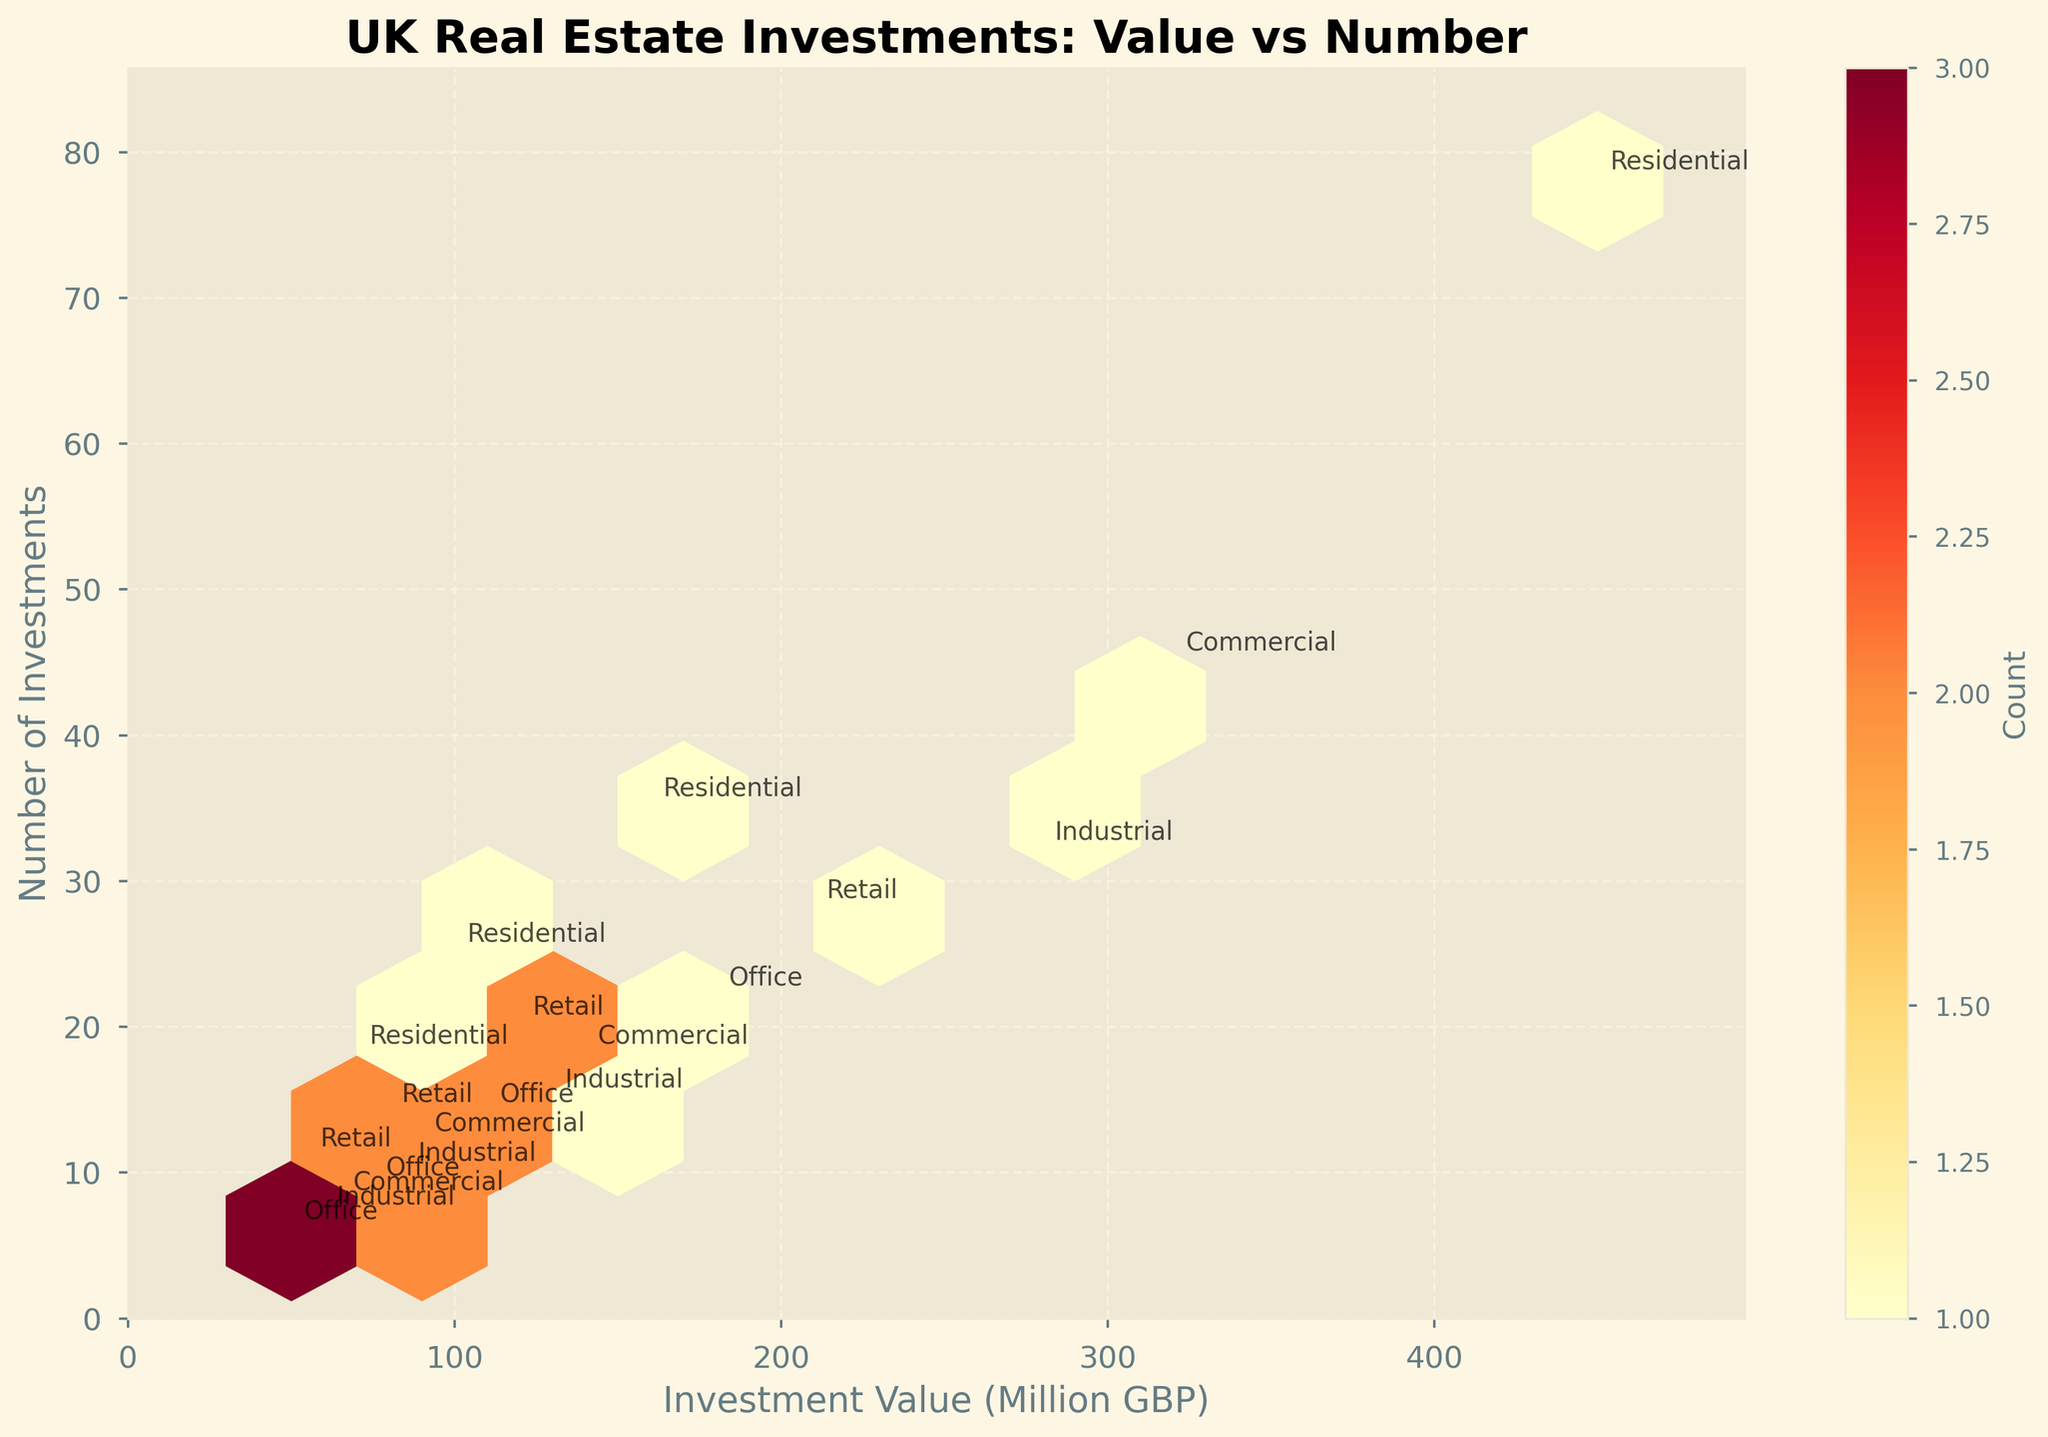What is the title of the figure? The title of the figure is usually found at the top of the plot. In this case, it is "UK Real Estate Investments: Value vs Number" as specified in the code.
Answer: UK Real Estate Investments: Value vs Number What do the axes represent? The x-axis represents the "Investment Value (Million GBP)" and the y-axis represents the "Number of Investments," as labeled in the figure.
Answer: Investment Value (Million GBP) and Number of Investments How many data points are there for Residential properties? There are several points labeled "Residential" across different locations. By inspecting the figure, you can count the annotations to determine there are 5 such points.
Answer: 5 Which property types have the highest and lowest investment values? To find the highest and lowest investment values, you look at the extremes on the x-axis and check the labeled points. Residential in London represents the highest value, while Office in Reading is the lowest.
Answer: Residential in London and Office in Reading How many property types have more than 20 investments? By counting the number of points where the y-values are greater than 20 and inspecting the property type labels, you can determine that Residential in London, Residential in Bristol, and Residential in Newcastle meet this criterion.
Answer: 3 What does the color gradient in the hexbin plot indicate? The color gradient of a hexbin plot typically indicates the density of the data points in that hexagon. In this plot, the color ranges from light yellow (lower density) to dark red (higher density).
Answer: Density of data points What is the average investment value of Commercial properties? Commercial properties have investment values of 320 (Manchester), 140 (Leeds), 90 (Nottingham), and 65 (Cambridge). Summing these values gives 615. Dividing by 4 gives an average of approximately 153.75 million GBP.
Answer: 153.75 million GBP Which city has the highest number of investments in the Retail property type? To find this, look at the y-values of points labeled "Retail." Edinburgh represents the highest number, with a value of 28.
Answer: Edinburgh How does the density of investments compare between Residential and Industrial property types? Observing the color density in hexbin regions marked with "Residential" and "Industrial" will show that Residential has higher density areas (darker red hexagons) compared to Industrial, which has lighter hexagons.
Answer: Residential is denser than Industrial Which property type is located at the intersection of the highest investment value and number of investments? By identifying the top-right point on the plot, you can see that the Residential property type in London has both the highest investment value (450 million GBP) and the highest number of investments (78).
Answer: Residential in London 